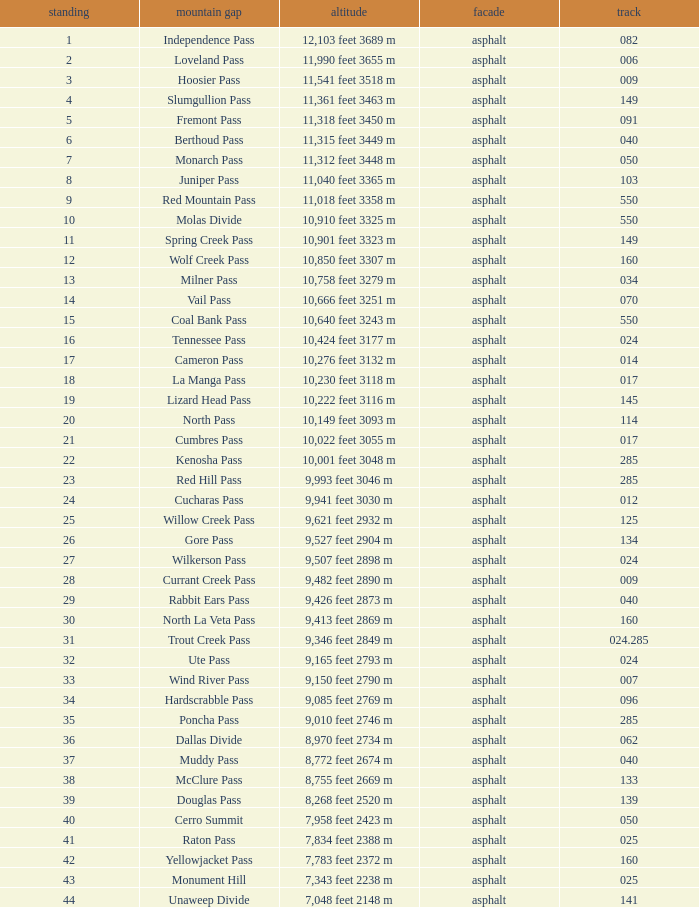What is the Elevation of the mountain on Route 62? 8,970 feet 2734 m. 